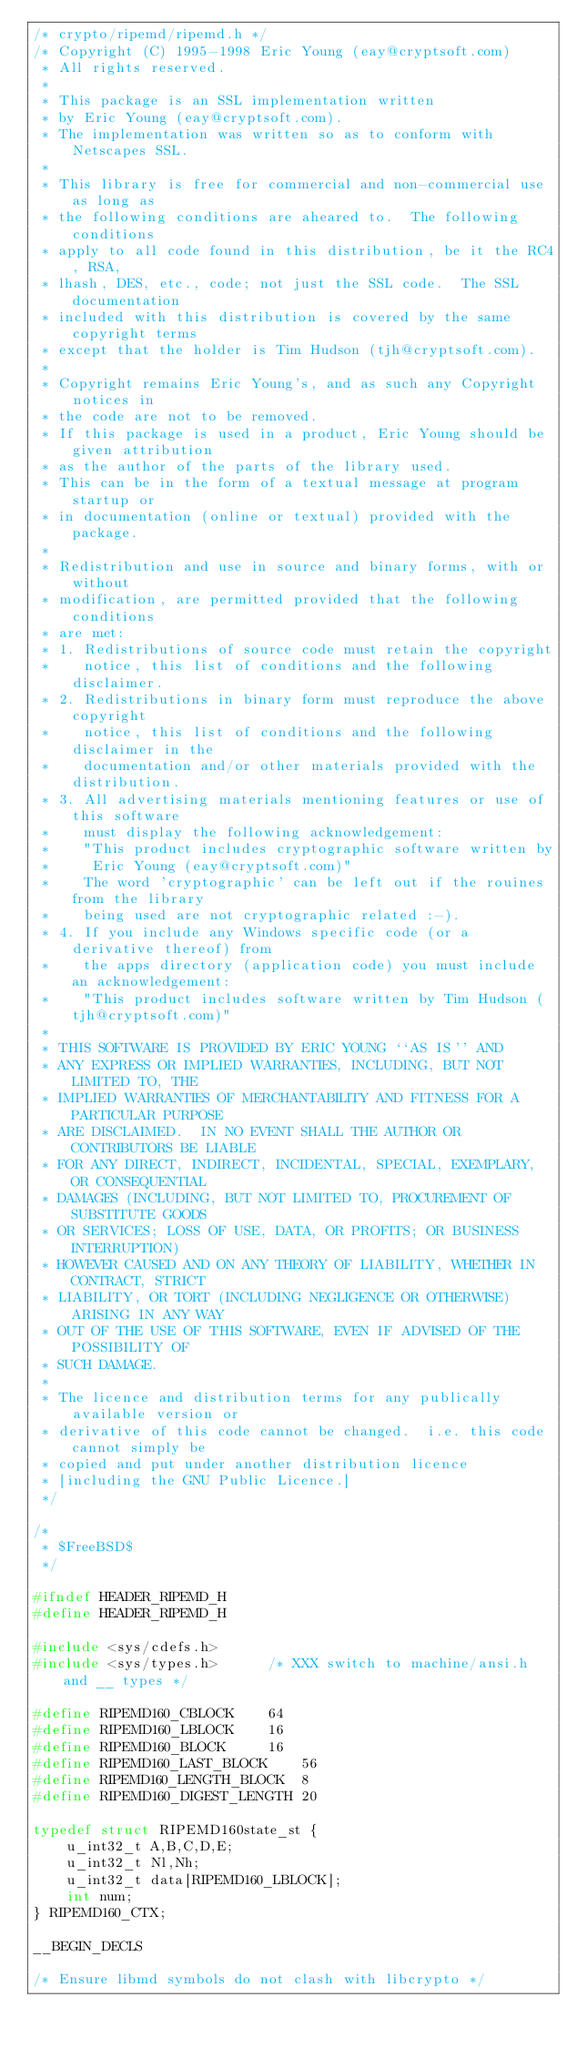Convert code to text. <code><loc_0><loc_0><loc_500><loc_500><_C_>/* crypto/ripemd/ripemd.h */
/* Copyright (C) 1995-1998 Eric Young (eay@cryptsoft.com)
 * All rights reserved.
 *
 * This package is an SSL implementation written
 * by Eric Young (eay@cryptsoft.com).
 * The implementation was written so as to conform with Netscapes SSL.
 * 
 * This library is free for commercial and non-commercial use as long as
 * the following conditions are aheared to.  The following conditions
 * apply to all code found in this distribution, be it the RC4, RSA,
 * lhash, DES, etc., code; not just the SSL code.  The SSL documentation
 * included with this distribution is covered by the same copyright terms
 * except that the holder is Tim Hudson (tjh@cryptsoft.com).
 * 
 * Copyright remains Eric Young's, and as such any Copyright notices in
 * the code are not to be removed.
 * If this package is used in a product, Eric Young should be given attribution
 * as the author of the parts of the library used.
 * This can be in the form of a textual message at program startup or
 * in documentation (online or textual) provided with the package.
 * 
 * Redistribution and use in source and binary forms, with or without
 * modification, are permitted provided that the following conditions
 * are met:
 * 1. Redistributions of source code must retain the copyright
 *    notice, this list of conditions and the following disclaimer.
 * 2. Redistributions in binary form must reproduce the above copyright
 *    notice, this list of conditions and the following disclaimer in the
 *    documentation and/or other materials provided with the distribution.
 * 3. All advertising materials mentioning features or use of this software
 *    must display the following acknowledgement:
 *    "This product includes cryptographic software written by
 *     Eric Young (eay@cryptsoft.com)"
 *    The word 'cryptographic' can be left out if the rouines from the library
 *    being used are not cryptographic related :-).
 * 4. If you include any Windows specific code (or a derivative thereof) from 
 *    the apps directory (application code) you must include an acknowledgement:
 *    "This product includes software written by Tim Hudson (tjh@cryptsoft.com)"
 * 
 * THIS SOFTWARE IS PROVIDED BY ERIC YOUNG ``AS IS'' AND
 * ANY EXPRESS OR IMPLIED WARRANTIES, INCLUDING, BUT NOT LIMITED TO, THE
 * IMPLIED WARRANTIES OF MERCHANTABILITY AND FITNESS FOR A PARTICULAR PURPOSE
 * ARE DISCLAIMED.  IN NO EVENT SHALL THE AUTHOR OR CONTRIBUTORS BE LIABLE
 * FOR ANY DIRECT, INDIRECT, INCIDENTAL, SPECIAL, EXEMPLARY, OR CONSEQUENTIAL
 * DAMAGES (INCLUDING, BUT NOT LIMITED TO, PROCUREMENT OF SUBSTITUTE GOODS
 * OR SERVICES; LOSS OF USE, DATA, OR PROFITS; OR BUSINESS INTERRUPTION)
 * HOWEVER CAUSED AND ON ANY THEORY OF LIABILITY, WHETHER IN CONTRACT, STRICT
 * LIABILITY, OR TORT (INCLUDING NEGLIGENCE OR OTHERWISE) ARISING IN ANY WAY
 * OUT OF THE USE OF THIS SOFTWARE, EVEN IF ADVISED OF THE POSSIBILITY OF
 * SUCH DAMAGE.
 * 
 * The licence and distribution terms for any publically available version or
 * derivative of this code cannot be changed.  i.e. this code cannot simply be
 * copied and put under another distribution licence
 * [including the GNU Public Licence.]
 */

/*
 * $FreeBSD$
 */

#ifndef HEADER_RIPEMD_H
#define HEADER_RIPEMD_H

#include <sys/cdefs.h>
#include <sys/types.h>		/* XXX switch to machine/ansi.h and __ types */

#define RIPEMD160_CBLOCK	64
#define RIPEMD160_LBLOCK	16
#define RIPEMD160_BLOCK		16
#define RIPEMD160_LAST_BLOCK	56
#define RIPEMD160_LENGTH_BLOCK	8
#define RIPEMD160_DIGEST_LENGTH	20

typedef struct RIPEMD160state_st {
	u_int32_t A,B,C,D,E;
	u_int32_t Nl,Nh;
	u_int32_t data[RIPEMD160_LBLOCK];
	int num;
} RIPEMD160_CTX;

__BEGIN_DECLS

/* Ensure libmd symbols do not clash with libcrypto */
</code> 